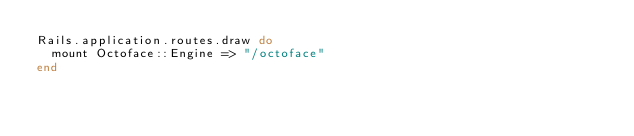<code> <loc_0><loc_0><loc_500><loc_500><_Ruby_>Rails.application.routes.draw do
  mount Octoface::Engine => "/octoface"
end
</code> 